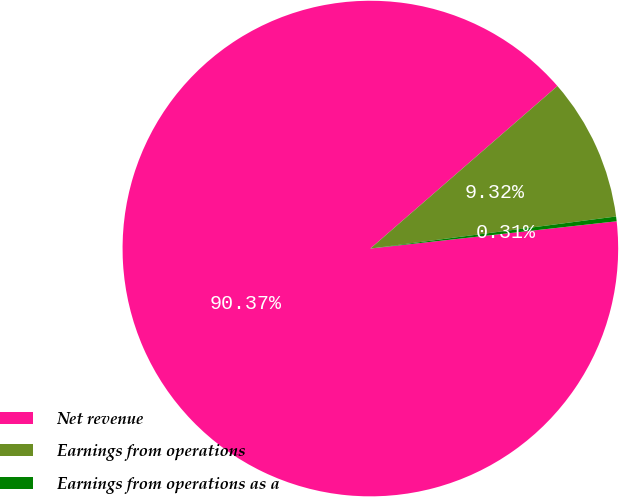<chart> <loc_0><loc_0><loc_500><loc_500><pie_chart><fcel>Net revenue<fcel>Earnings from operations<fcel>Earnings from operations as a<nl><fcel>90.38%<fcel>9.32%<fcel>0.31%<nl></chart> 